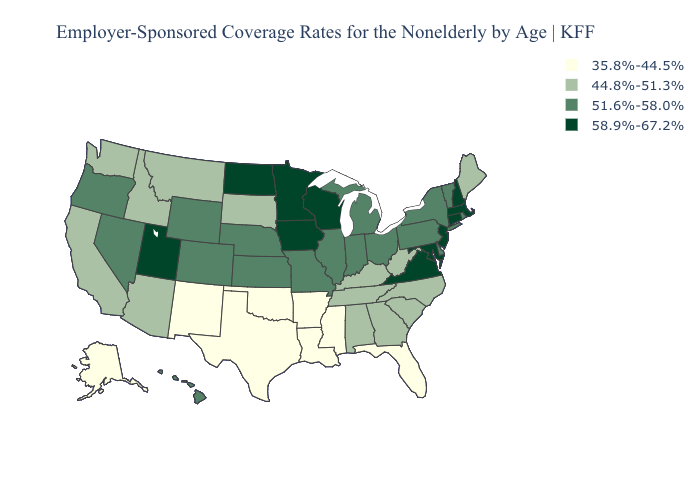What is the value of Kentucky?
Keep it brief. 44.8%-51.3%. What is the value of Kansas?
Give a very brief answer. 51.6%-58.0%. Among the states that border Iowa , does Missouri have the highest value?
Be succinct. No. What is the value of Alaska?
Short answer required. 35.8%-44.5%. Name the states that have a value in the range 44.8%-51.3%?
Keep it brief. Alabama, Arizona, California, Georgia, Idaho, Kentucky, Maine, Montana, North Carolina, South Carolina, South Dakota, Tennessee, Washington, West Virginia. Which states hav the highest value in the South?
Write a very short answer. Maryland, Virginia. What is the highest value in states that border Mississippi?
Write a very short answer. 44.8%-51.3%. What is the highest value in the MidWest ?
Answer briefly. 58.9%-67.2%. Name the states that have a value in the range 58.9%-67.2%?
Quick response, please. Connecticut, Iowa, Maryland, Massachusetts, Minnesota, New Hampshire, New Jersey, North Dakota, Utah, Virginia, Wisconsin. Among the states that border Ohio , which have the highest value?
Be succinct. Indiana, Michigan, Pennsylvania. Does Minnesota have a higher value than New Jersey?
Be succinct. No. What is the value of Kansas?
Short answer required. 51.6%-58.0%. What is the value of Maine?
Concise answer only. 44.8%-51.3%. What is the lowest value in the USA?
Give a very brief answer. 35.8%-44.5%. 